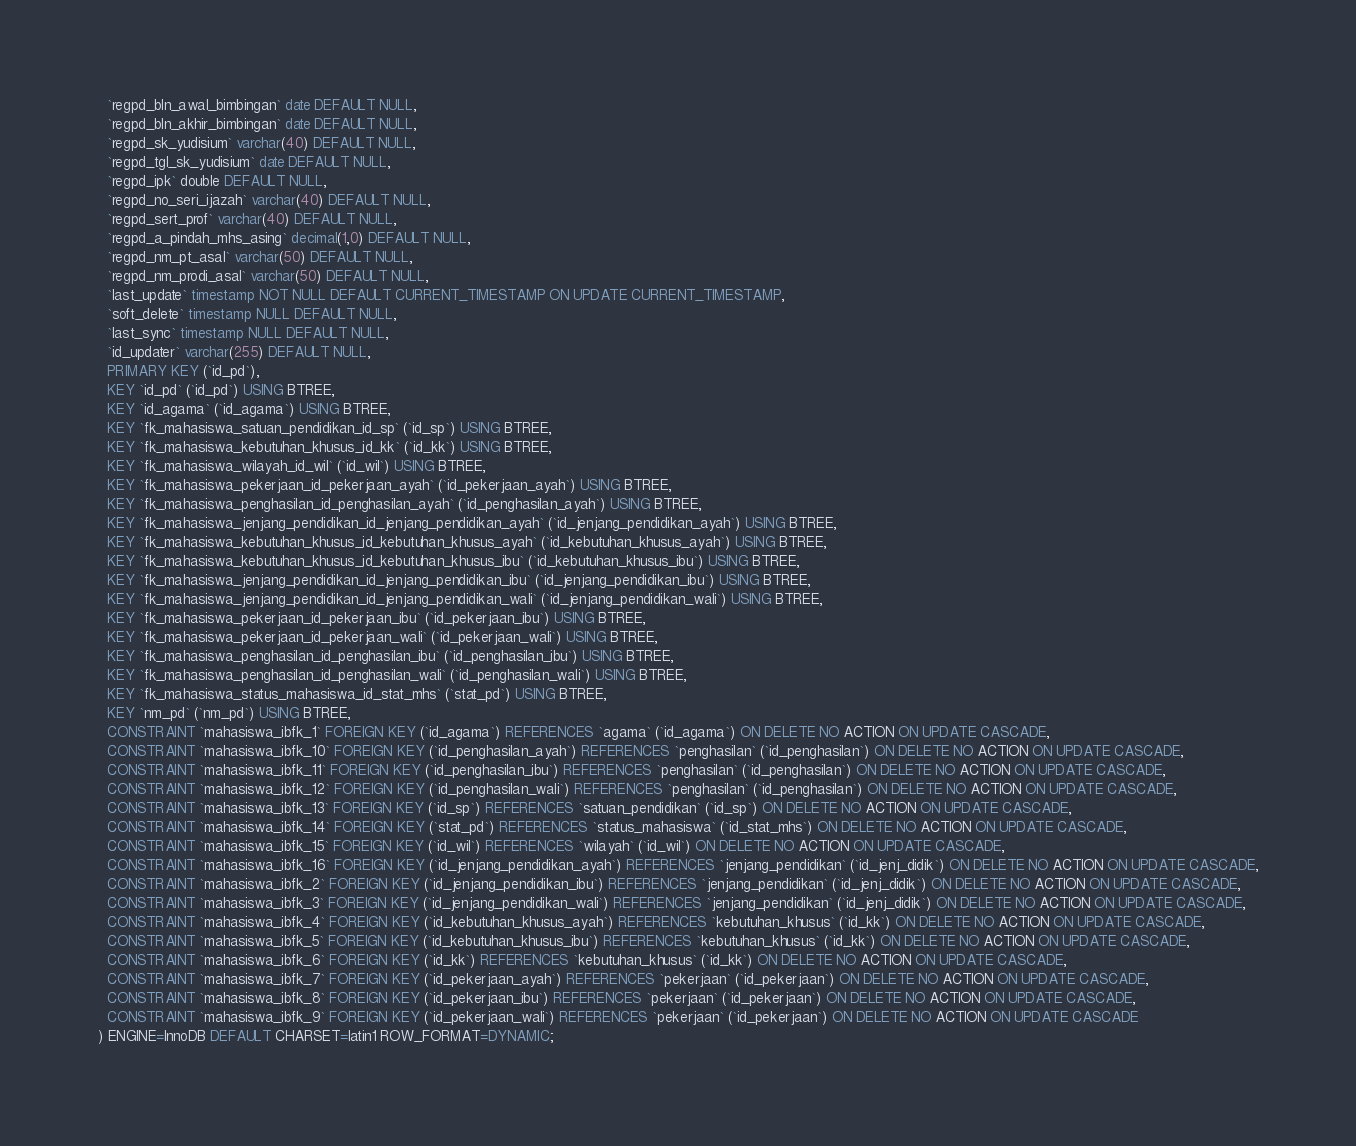Convert code to text. <code><loc_0><loc_0><loc_500><loc_500><_SQL_>  `regpd_bln_awal_bimbingan` date DEFAULT NULL,
  `regpd_bln_akhir_bimbingan` date DEFAULT NULL,
  `regpd_sk_yudisium` varchar(40) DEFAULT NULL,
  `regpd_tgl_sk_yudisium` date DEFAULT NULL,
  `regpd_ipk` double DEFAULT NULL,
  `regpd_no_seri_ijazah` varchar(40) DEFAULT NULL,
  `regpd_sert_prof` varchar(40) DEFAULT NULL,
  `regpd_a_pindah_mhs_asing` decimal(1,0) DEFAULT NULL,
  `regpd_nm_pt_asal` varchar(50) DEFAULT NULL,
  `regpd_nm_prodi_asal` varchar(50) DEFAULT NULL,
  `last_update` timestamp NOT NULL DEFAULT CURRENT_TIMESTAMP ON UPDATE CURRENT_TIMESTAMP,
  `soft_delete` timestamp NULL DEFAULT NULL,
  `last_sync` timestamp NULL DEFAULT NULL,
  `id_updater` varchar(255) DEFAULT NULL,
  PRIMARY KEY (`id_pd`),
  KEY `id_pd` (`id_pd`) USING BTREE,
  KEY `id_agama` (`id_agama`) USING BTREE,
  KEY `fk_mahasiswa_satuan_pendidikan_id_sp` (`id_sp`) USING BTREE,
  KEY `fk_mahasiswa_kebutuhan_khusus_id_kk` (`id_kk`) USING BTREE,
  KEY `fk_mahasiswa_wilayah_id_wil` (`id_wil`) USING BTREE,
  KEY `fk_mahasiswa_pekerjaan_id_pekerjaan_ayah` (`id_pekerjaan_ayah`) USING BTREE,
  KEY `fk_mahasiswa_penghasilan_id_penghasilan_ayah` (`id_penghasilan_ayah`) USING BTREE,
  KEY `fk_mahasiswa_jenjang_pendidikan_id_jenjang_pendidikan_ayah` (`id_jenjang_pendidikan_ayah`) USING BTREE,
  KEY `fk_mahasiswa_kebutuhan_khusus_id_kebutuhan_khusus_ayah` (`id_kebutuhan_khusus_ayah`) USING BTREE,
  KEY `fk_mahasiswa_kebutuhan_khusus_id_kebutuhan_khusus_ibu` (`id_kebutuhan_khusus_ibu`) USING BTREE,
  KEY `fk_mahasiswa_jenjang_pendidikan_id_jenjang_pendidikan_ibu` (`id_jenjang_pendidikan_ibu`) USING BTREE,
  KEY `fk_mahasiswa_jenjang_pendidikan_id_jenjang_pendidikan_wali` (`id_jenjang_pendidikan_wali`) USING BTREE,
  KEY `fk_mahasiswa_pekerjaan_id_pekerjaan_ibu` (`id_pekerjaan_ibu`) USING BTREE,
  KEY `fk_mahasiswa_pekerjaan_id_pekerjaan_wali` (`id_pekerjaan_wali`) USING BTREE,
  KEY `fk_mahasiswa_penghasilan_id_penghasilan_ibu` (`id_penghasilan_ibu`) USING BTREE,
  KEY `fk_mahasiswa_penghasilan_id_penghasilan_wali` (`id_penghasilan_wali`) USING BTREE,
  KEY `fk_mahasiswa_status_mahasiswa_id_stat_mhs` (`stat_pd`) USING BTREE,
  KEY `nm_pd` (`nm_pd`) USING BTREE,
  CONSTRAINT `mahasiswa_ibfk_1` FOREIGN KEY (`id_agama`) REFERENCES `agama` (`id_agama`) ON DELETE NO ACTION ON UPDATE CASCADE,
  CONSTRAINT `mahasiswa_ibfk_10` FOREIGN KEY (`id_penghasilan_ayah`) REFERENCES `penghasilan` (`id_penghasilan`) ON DELETE NO ACTION ON UPDATE CASCADE,
  CONSTRAINT `mahasiswa_ibfk_11` FOREIGN KEY (`id_penghasilan_ibu`) REFERENCES `penghasilan` (`id_penghasilan`) ON DELETE NO ACTION ON UPDATE CASCADE,
  CONSTRAINT `mahasiswa_ibfk_12` FOREIGN KEY (`id_penghasilan_wali`) REFERENCES `penghasilan` (`id_penghasilan`) ON DELETE NO ACTION ON UPDATE CASCADE,
  CONSTRAINT `mahasiswa_ibfk_13` FOREIGN KEY (`id_sp`) REFERENCES `satuan_pendidikan` (`id_sp`) ON DELETE NO ACTION ON UPDATE CASCADE,
  CONSTRAINT `mahasiswa_ibfk_14` FOREIGN KEY (`stat_pd`) REFERENCES `status_mahasiswa` (`id_stat_mhs`) ON DELETE NO ACTION ON UPDATE CASCADE,
  CONSTRAINT `mahasiswa_ibfk_15` FOREIGN KEY (`id_wil`) REFERENCES `wilayah` (`id_wil`) ON DELETE NO ACTION ON UPDATE CASCADE,
  CONSTRAINT `mahasiswa_ibfk_16` FOREIGN KEY (`id_jenjang_pendidikan_ayah`) REFERENCES `jenjang_pendidikan` (`id_jenj_didik`) ON DELETE NO ACTION ON UPDATE CASCADE,
  CONSTRAINT `mahasiswa_ibfk_2` FOREIGN KEY (`id_jenjang_pendidikan_ibu`) REFERENCES `jenjang_pendidikan` (`id_jenj_didik`) ON DELETE NO ACTION ON UPDATE CASCADE,
  CONSTRAINT `mahasiswa_ibfk_3` FOREIGN KEY (`id_jenjang_pendidikan_wali`) REFERENCES `jenjang_pendidikan` (`id_jenj_didik`) ON DELETE NO ACTION ON UPDATE CASCADE,
  CONSTRAINT `mahasiswa_ibfk_4` FOREIGN KEY (`id_kebutuhan_khusus_ayah`) REFERENCES `kebutuhan_khusus` (`id_kk`) ON DELETE NO ACTION ON UPDATE CASCADE,
  CONSTRAINT `mahasiswa_ibfk_5` FOREIGN KEY (`id_kebutuhan_khusus_ibu`) REFERENCES `kebutuhan_khusus` (`id_kk`) ON DELETE NO ACTION ON UPDATE CASCADE,
  CONSTRAINT `mahasiswa_ibfk_6` FOREIGN KEY (`id_kk`) REFERENCES `kebutuhan_khusus` (`id_kk`) ON DELETE NO ACTION ON UPDATE CASCADE,
  CONSTRAINT `mahasiswa_ibfk_7` FOREIGN KEY (`id_pekerjaan_ayah`) REFERENCES `pekerjaan` (`id_pekerjaan`) ON DELETE NO ACTION ON UPDATE CASCADE,
  CONSTRAINT `mahasiswa_ibfk_8` FOREIGN KEY (`id_pekerjaan_ibu`) REFERENCES `pekerjaan` (`id_pekerjaan`) ON DELETE NO ACTION ON UPDATE CASCADE,
  CONSTRAINT `mahasiswa_ibfk_9` FOREIGN KEY (`id_pekerjaan_wali`) REFERENCES `pekerjaan` (`id_pekerjaan`) ON DELETE NO ACTION ON UPDATE CASCADE
) ENGINE=InnoDB DEFAULT CHARSET=latin1 ROW_FORMAT=DYNAMIC;</code> 